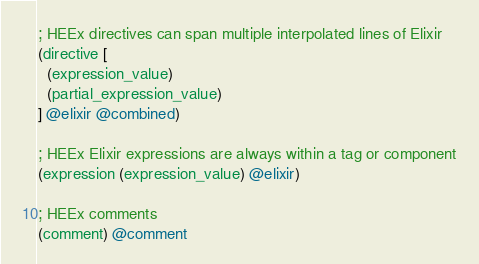Convert code to text. <code><loc_0><loc_0><loc_500><loc_500><_Scheme_>; HEEx directives can span multiple interpolated lines of Elixir
(directive [
  (expression_value) 
  (partial_expression_value)
] @elixir @combined)  

; HEEx Elixir expressions are always within a tag or component
(expression (expression_value) @elixir)

; HEEx comments
(comment) @comment
</code> 